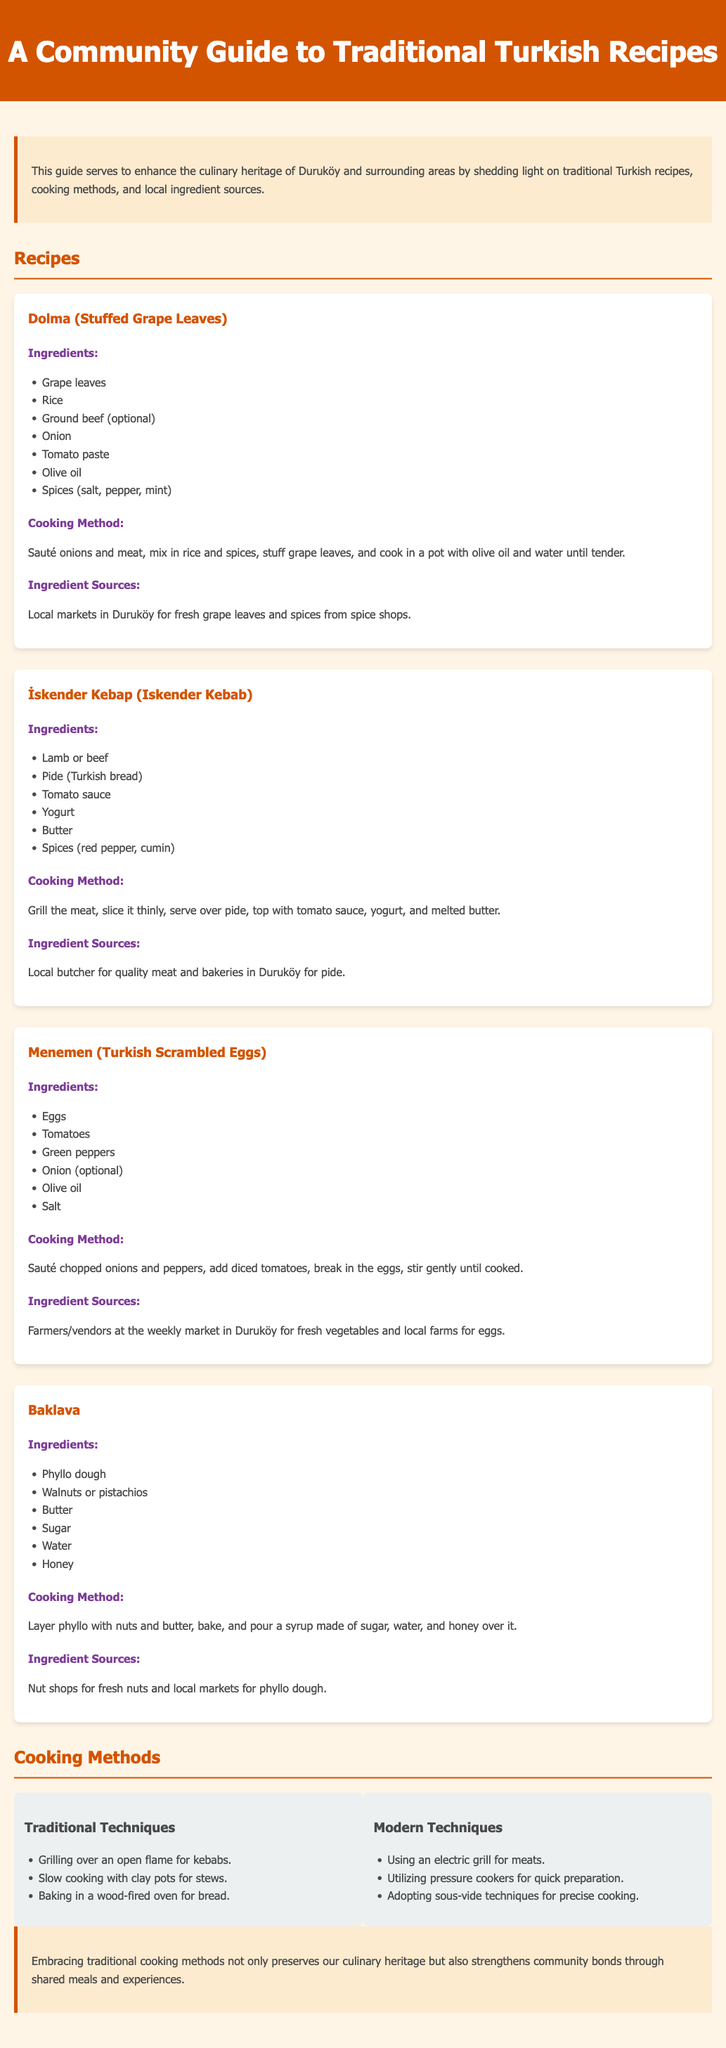What is the first recipe listed in the document? The document lists "Dolma (Stuffed Grape Leaves)" as the first recipe under the Recipes section.
Answer: Dolma (Stuffed Grape Leaves) Which ingredient is optional in the İskender Kebap recipe? The ingredient "pide" is mentioned as a key component, while "butter" is also listed, but "ground beef" is indicated as optional.
Answer: Ground beef What cooking method is used for Baklava? The preparation of Baklava involves layering and baking, which is described in the cooking method section under its recipe.
Answer: Baking How many Traditional Techniques are listed? The document provides three traditional cooking techniques under the Cooking Methods section.
Answer: Three Where can fresh grape leaves be sourced? The document states that fresh grape leaves can be sourced from local markets in Duruköy.
Answer: Local markets in Duruköy What type of cooking technique is utilized for quickly preparing meals? The document mentions using "pressure cookers" as one of the modern cooking techniques for quicker meal preparation.
Answer: Pressure cookers Which dessert is featured at the end of the Recipes section? The last recipe presented in the document is for "Baklava".
Answer: Baklava What color are the section headings in the document? The section headings are styled with the color "#D35400", as indicated in the document’s CSS section.
Answer: #D35400 